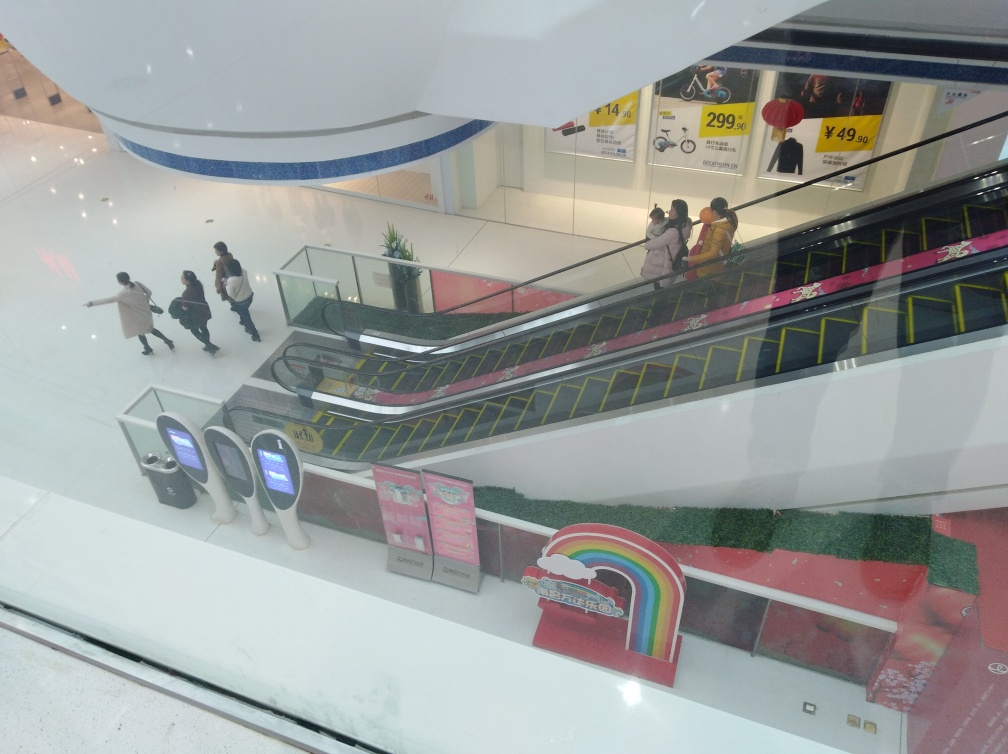Are there any unique features or decorations in this setting? There is a colorful feature at the bottom left corner of the image, resembling a rainbow, which stands out against the more neutral colors of the surroundings. Additionally, there are advertisements and signage that add visual interest and information for the visitors of the establishment. What might the rainbow structure be used for? The rainbow structure, given its playful and vibrant colors, might be decorative or part of a promotional display. Its placement and design suggest it could be appealing to younger audiences or part of a marketing campaign intended to catch the eye of shoppers and create a photo opportunity. 